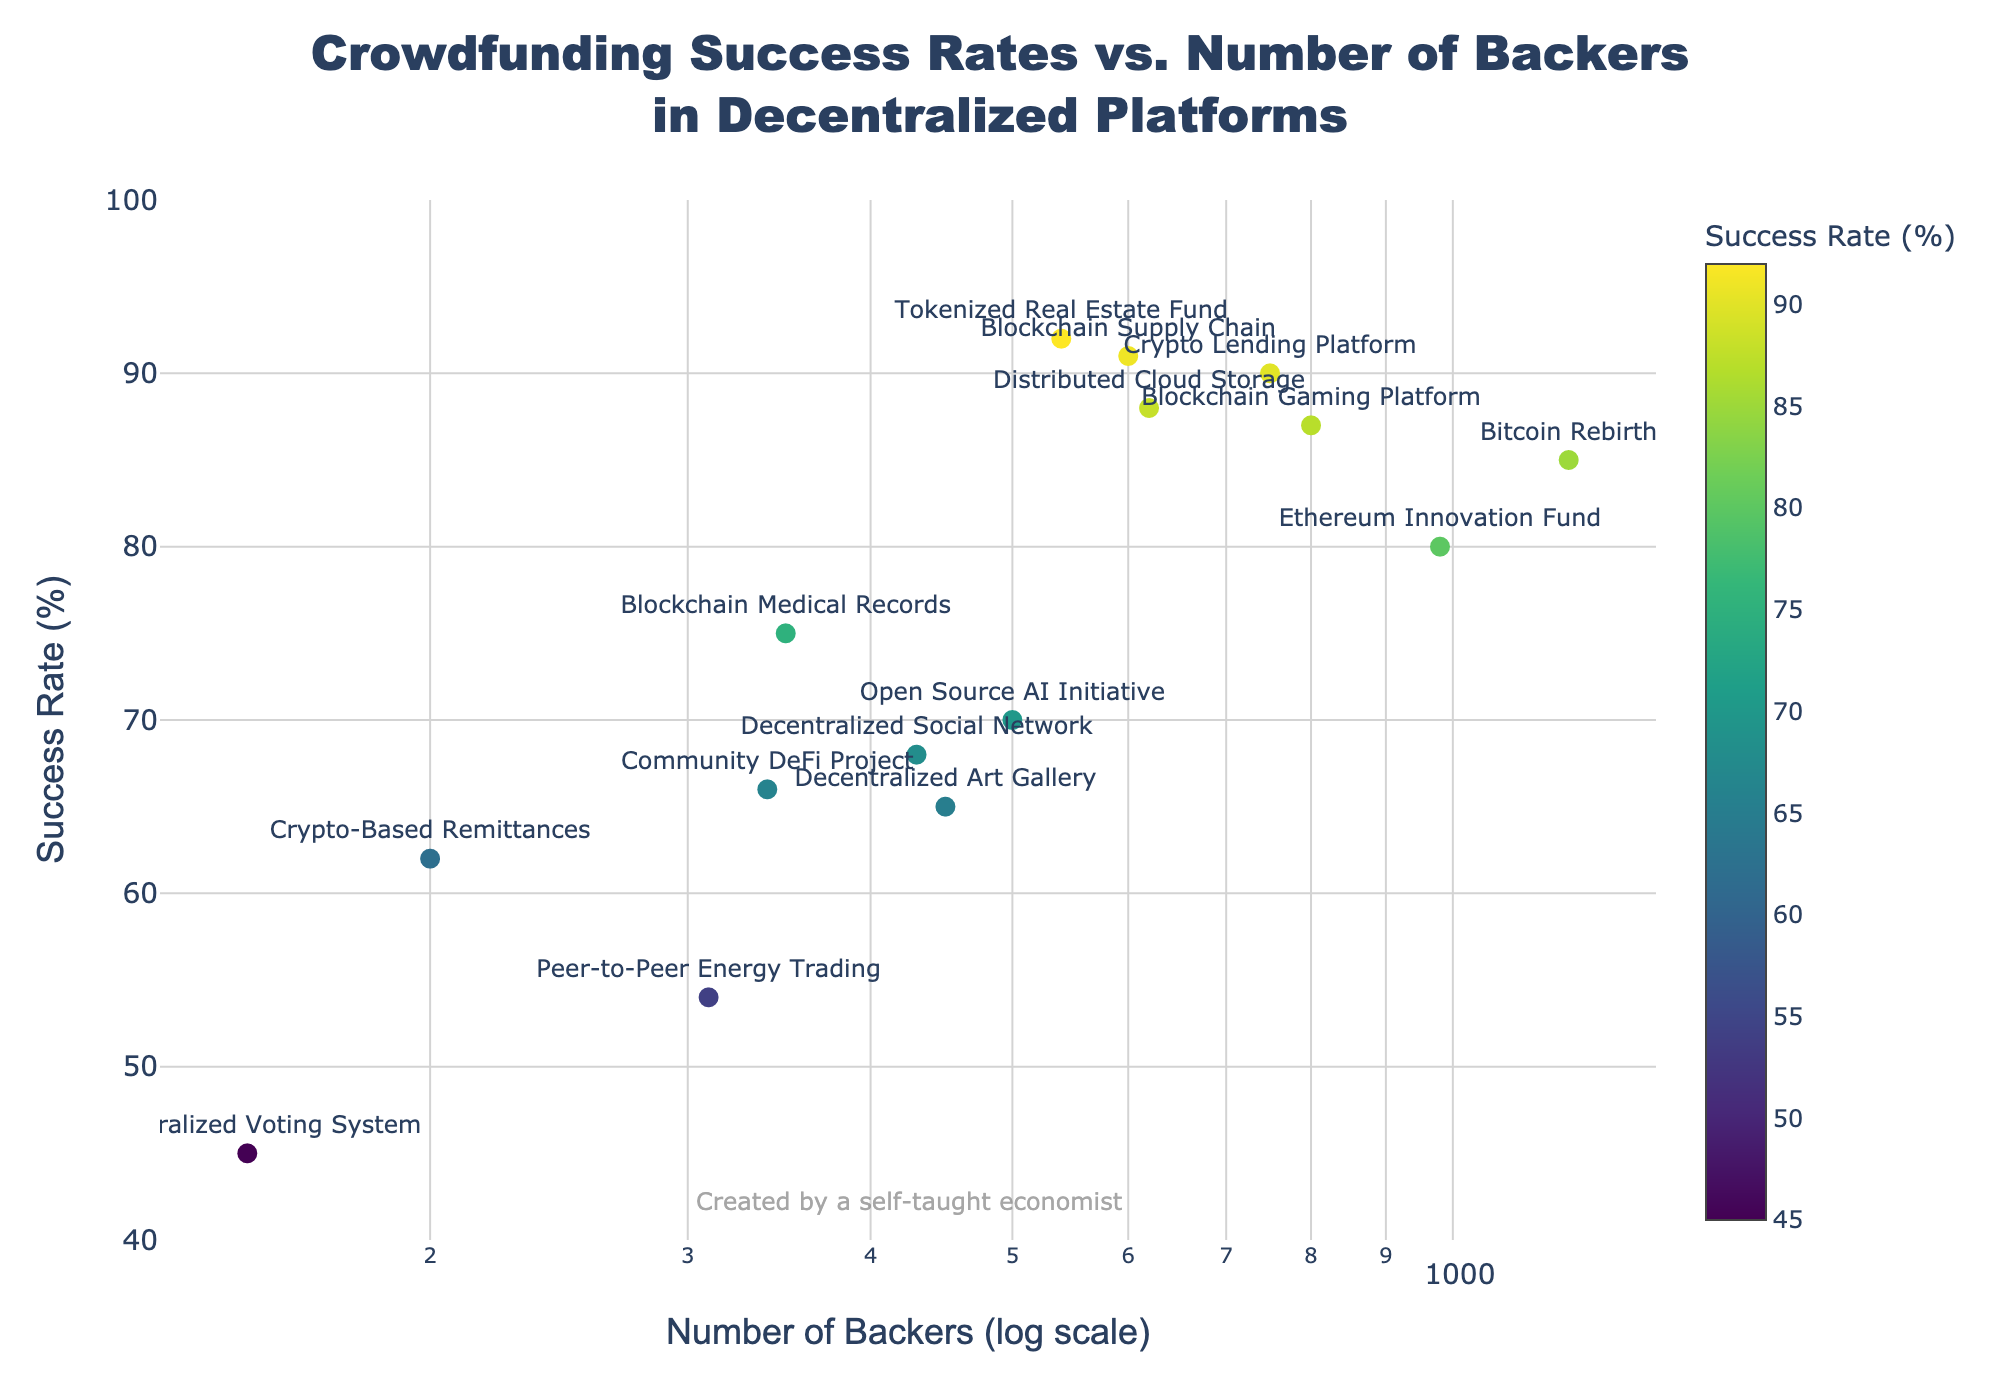What's the title of the figure? The title of the figure is located at the top center of the plot and typically states the main topic represented in the visualization.
Answer: Crowdfunding Success Rates vs. Number of Backers in Decentralized Platforms What does the y-axis represent in this scatter plot? The y-axis represents the vertical component of the plot, which, based on the data provided, indicates the success rate percentage of the crowdfunding projects.
Answer: Success Rate (%) Which project has the highest success rate? By analyzing the markers and their corresponding labels, the project with the highest position on the y-axis represents the highest success rate.
Answer: Tokenized Real Estate Fund How many projects have a success rate above 80%? Examining the y-axis, count how many of the projects' markers are positioned above the 80% mark.
Answer: 7 What is the range of the y-axis in the plot? By examining the lower and upper bounds of the y-axis, we can determine the visible range set for the success rate percentages.
Answer: 40% to 100% Which project has the lowest number of backers, and what is its success rate? Look for the marker farthest to the left, read its label for the project name, and then note its position on the y-axis for the success rate.
Answer: Decentralized Voting System, 45% What is the average success rate of projects with more than 500 backers? Identify the projects with more than 500 backers, sum their success rates, and divide by the number of such projects to find the average.
Answer: (85 + 80 + 90 + 88 + 87 + 91) / 6 = 520 / 6 ≈ 86.67% Compare the success rates of 'Decentralized Social Network' and 'Blockchain Supply Chain'. Which has a higher success rate? Locate the two projects on the scatter plot, and compare their y-axis positions to find which marker is higher.
Answer: Blockchain Supply Chain What does the x-axis of this scatter plot represent and what is special about its scale? The x-axis represents the number of backers for each project, and the log scale means that it is exponentially scaled rather than linearly.
Answer: Number of Backers (log scale) Which project has the closest success rate to the median of all success rates? List the success rates, find the median value, and then determine which project's success rate is closest to this median value.
Answer: Community DeFi Project (Median value is 70, and this project has a success rate of 66%) 